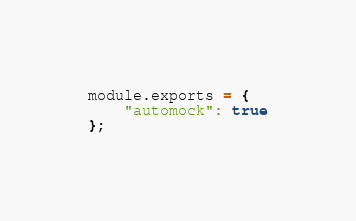Convert code to text. <code><loc_0><loc_0><loc_500><loc_500><_JavaScript_>module.exports = {
    "automock": true
};
</code> 